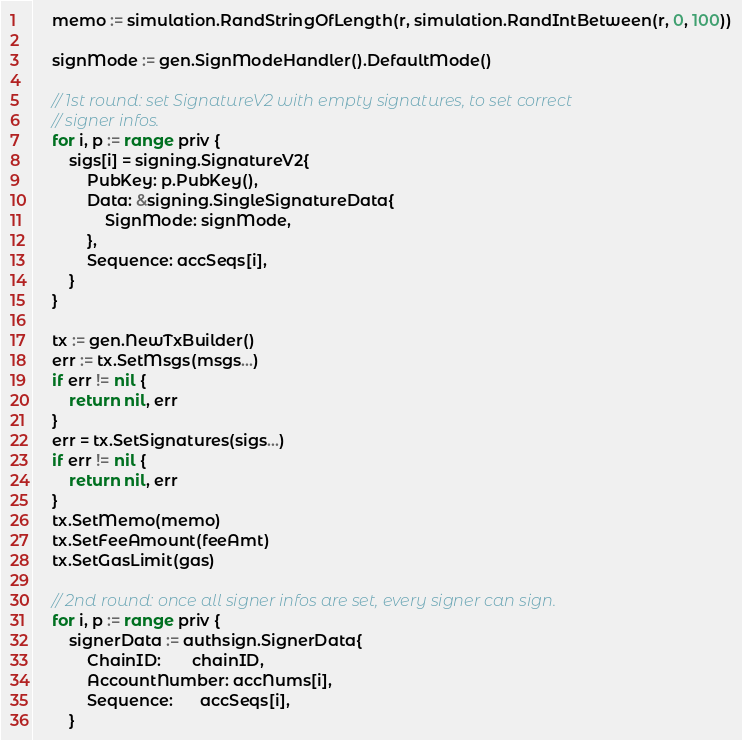<code> <loc_0><loc_0><loc_500><loc_500><_Go_>	memo := simulation.RandStringOfLength(r, simulation.RandIntBetween(r, 0, 100))

	signMode := gen.SignModeHandler().DefaultMode()

	// 1st round: set SignatureV2 with empty signatures, to set correct
	// signer infos.
	for i, p := range priv {
		sigs[i] = signing.SignatureV2{
			PubKey: p.PubKey(),
			Data: &signing.SingleSignatureData{
				SignMode: signMode,
			},
			Sequence: accSeqs[i],
		}
	}

	tx := gen.NewTxBuilder()
	err := tx.SetMsgs(msgs...)
	if err != nil {
		return nil, err
	}
	err = tx.SetSignatures(sigs...)
	if err != nil {
		return nil, err
	}
	tx.SetMemo(memo)
	tx.SetFeeAmount(feeAmt)
	tx.SetGasLimit(gas)

	// 2nd round: once all signer infos are set, every signer can sign.
	for i, p := range priv {
		signerData := authsign.SignerData{
			ChainID:       chainID,
			AccountNumber: accNums[i],
			Sequence:      accSeqs[i],
		}</code> 